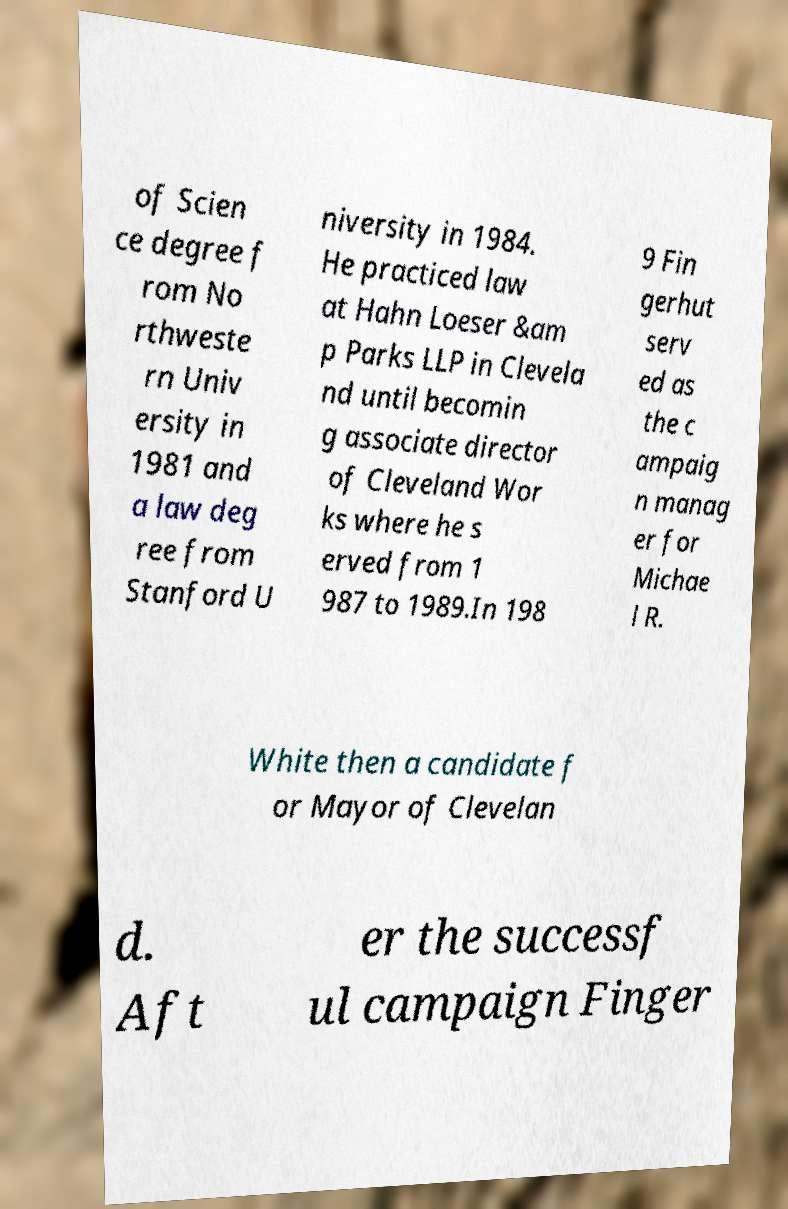Can you read and provide the text displayed in the image?This photo seems to have some interesting text. Can you extract and type it out for me? of Scien ce degree f rom No rthweste rn Univ ersity in 1981 and a law deg ree from Stanford U niversity in 1984. He practiced law at Hahn Loeser &am p Parks LLP in Clevela nd until becomin g associate director of Cleveland Wor ks where he s erved from 1 987 to 1989.In 198 9 Fin gerhut serv ed as the c ampaig n manag er for Michae l R. White then a candidate f or Mayor of Clevelan d. Aft er the successf ul campaign Finger 